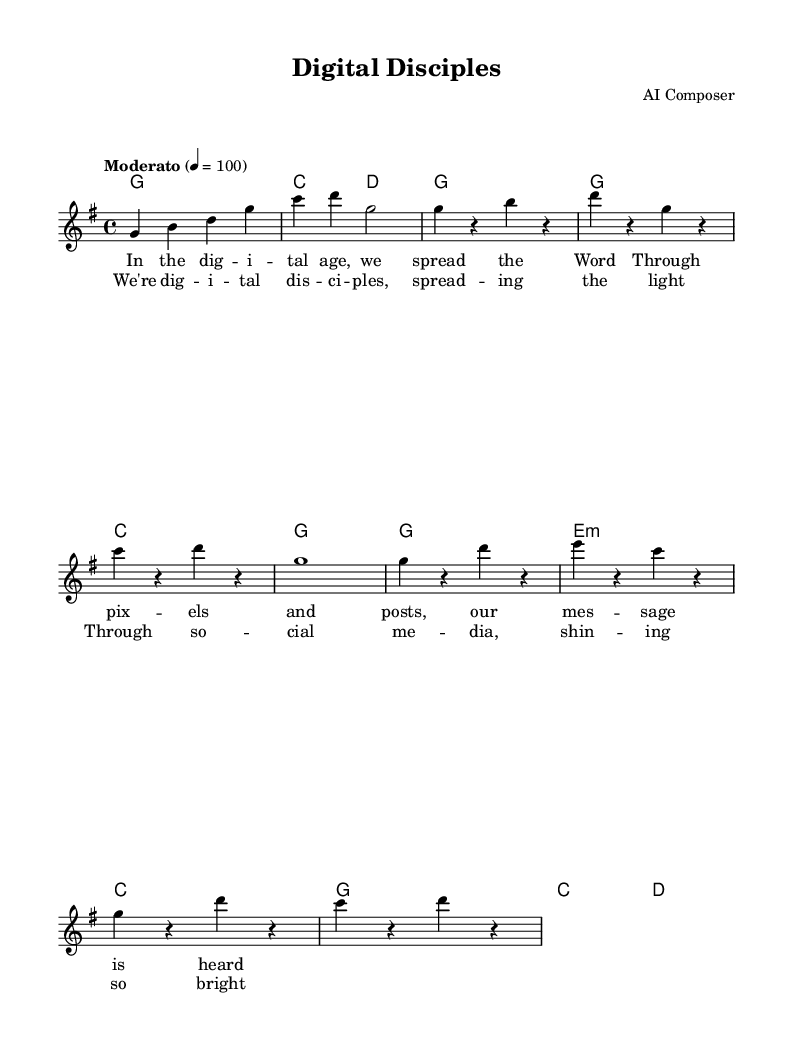What is the key signature of this music? The key signature indicates the tonal center of the piece. In this case, the key signature is G major, which has one sharp (F#). The "g" indicated in the global settings confirms this.
Answer: G major What is the time signature of this music? The time signature shows how many beats are in each measure and what note gets a beat. Here, it is 4/4, indicating there are 4 beats per measure and the quarter note gets one beat. This is directly noted as "4/4" in the global settings.
Answer: 4/4 What is the tempo marking given in the music? The tempo marking indicates the speed of the piece. It is specified as "Moderato," which suggests a moderate pace. This is reflected in the tempo instruction within the global section.
Answer: Moderato How many measures are in the chorus of this music? The chorus part consists of four measures, as indicated by the separation of sections where each line of the chorus corresponds to a measure. Counting the lines in the chorus lyrics confirms this.
Answer: 4 Which two chords are used in the introduction? The introduction contains two chords, as specified in the harmonies section. These chords, visually presented, are G major and C major (noted in the chord mode section).
Answer: G and C What is the central theme expressed in the lyrics? The lyrics depict the theme of utilizing digital platforms to share religious messages, highlighting the concept of digital evangelism in modern times. This interpretation is derived from the content of the lyrics presented under the verses.
Answer: Digital evangelism 